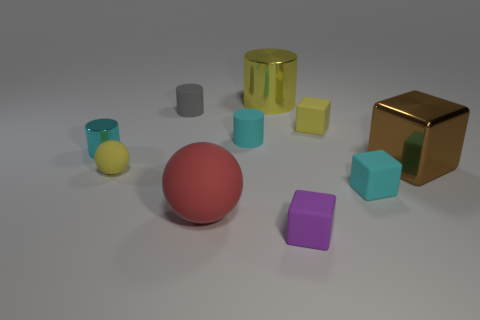Subtract all yellow rubber blocks. How many blocks are left? 3 Subtract 1 cylinders. How many cylinders are left? 3 Subtract all gray cubes. How many cyan cylinders are left? 2 Subtract all purple cubes. How many cubes are left? 3 Subtract all blocks. How many objects are left? 6 Subtract all gray blocks. Subtract all purple cylinders. How many blocks are left? 4 Subtract 0 gray spheres. How many objects are left? 10 Subtract all yellow metal things. Subtract all metallic cylinders. How many objects are left? 7 Add 6 yellow matte balls. How many yellow matte balls are left? 7 Add 3 cyan cylinders. How many cyan cylinders exist? 5 